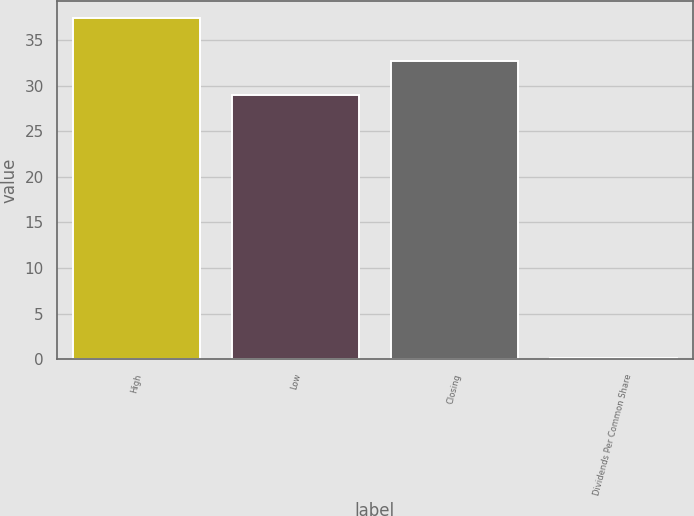<chart> <loc_0><loc_0><loc_500><loc_500><bar_chart><fcel>High<fcel>Low<fcel>Closing<fcel>Dividends Per Common Share<nl><fcel>37.39<fcel>28.97<fcel>32.7<fcel>0.14<nl></chart> 